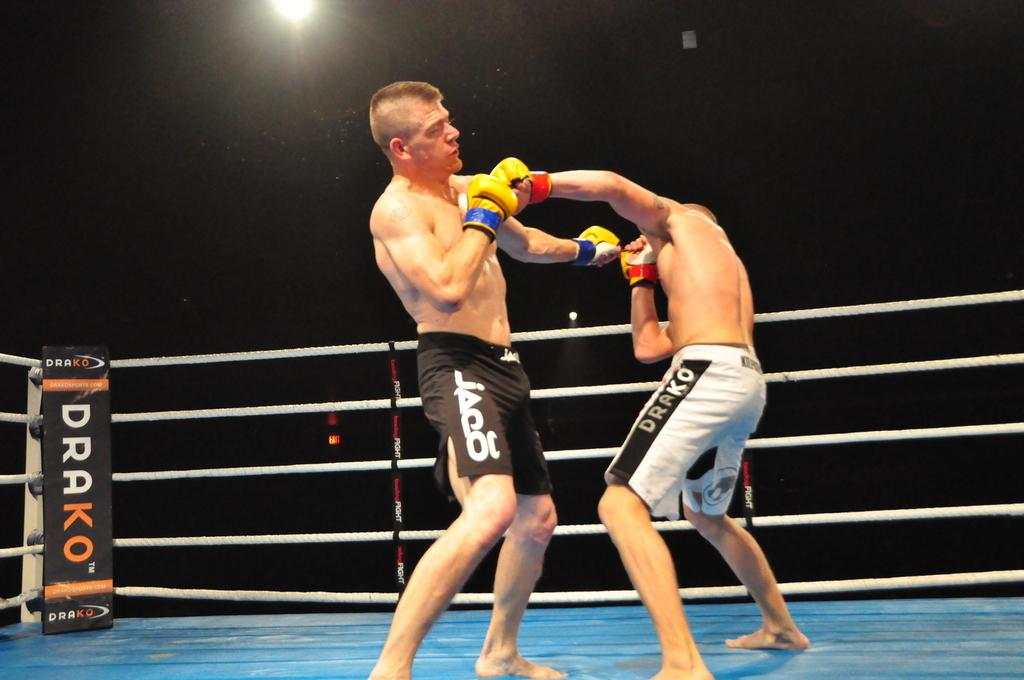<image>
Share a concise interpretation of the image provided. Two men are boxing in a ring that says Drako in the corner. 